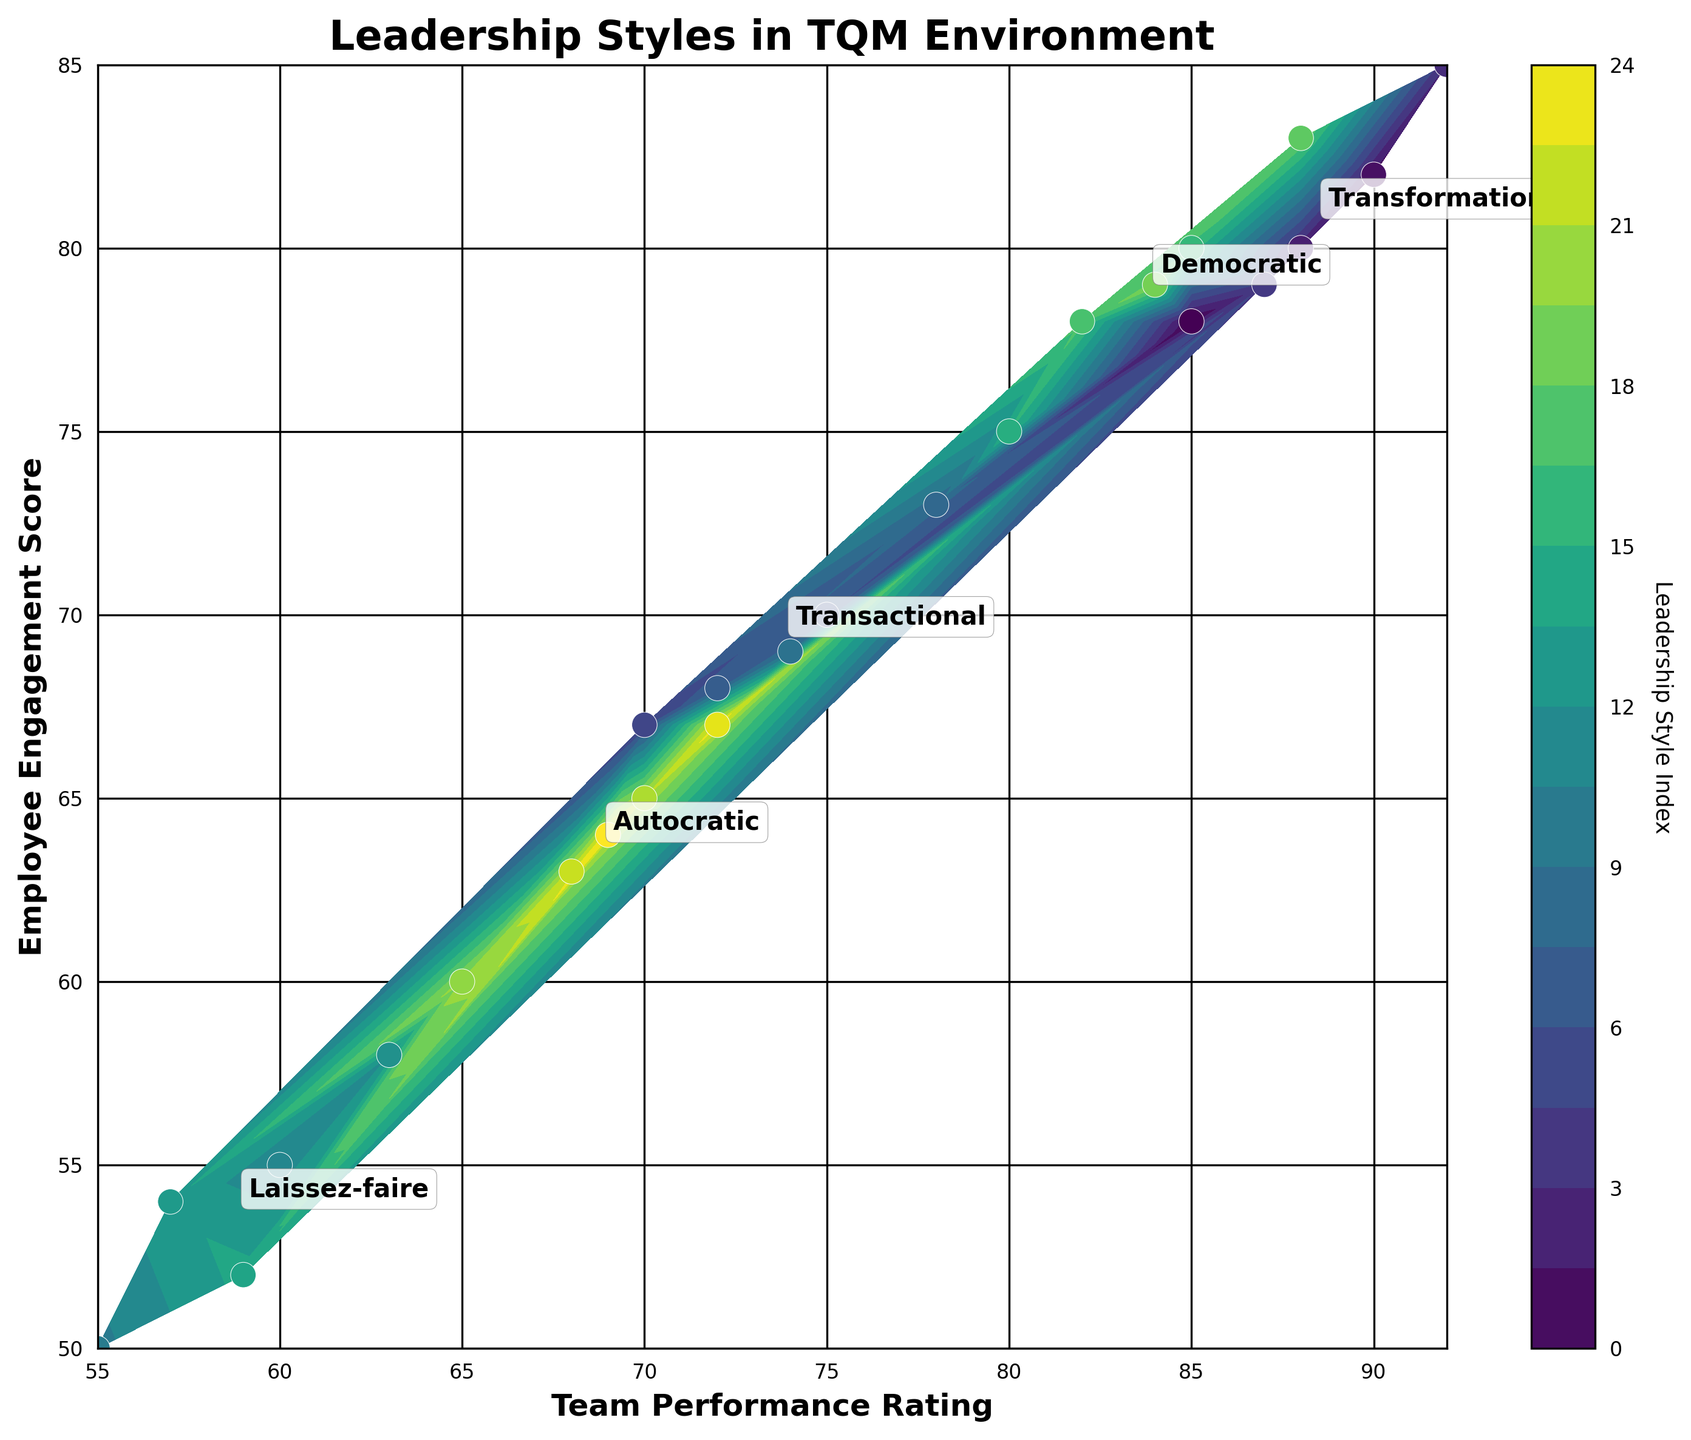What is the title of the plot? The title of a plot is usually found at the top of the figure. It summarizes what the plot is about in a concise manner. In this case, the title gives insight into the topic being visualized.
Answer: Leadership Styles in TQM Environment How many unique leadership styles are represented in the plot? The plot includes annotations for each leadership style, located near the clusters of data points that share the same style. By counting these annotations, we determine the number of unique styles.
Answer: 5 Which leadership style has the highest average Team Performance Rating? The annotations near the clusters indicate the mean Team Performance Rating for each leadership style. We compare these mean values to find the highest one.
Answer: Transformational What is the range of Employee Engagement Scores observed in the plot? Observing the y-axis, the lowest and highest Employee Engagement Scores can be identified. Subtracting the minimum value from the maximum value gives the range.
Answer: 50 to 85 Which leadership style shows the lowest Team Performance Rating? By examining the clusters of points and their annotations, the leadership style with data points furthest down the x-axis is identified.
Answer: Laissez-faire Compare the average Employee Engagement Score of Transformational and Autocratic leadership styles. Which is higher? The annotations near the data point clusters for each leadership style indicate their average Employee Engagement Scores. Comparing these values tells us which one is higher.
Answer: Transformational What color map is used for the contour plot? The specific color map (also known as the color palette or gradient) can be identified by observing the spectrum of colors used from the plot.
Answer: Viridis How do the Team Performance Ratings and Employee Engagement Scores for Transformational leadership compare to those for Laissez-faire leadership? To compare the data, we observe clusters and annotations for both Transformational and Laissez-faire leadership. Transformational has higher Team Performance Ratings and Employee Engagement Scores compared to Laissez-faire, based on their positions on the x and y axes.
Answer: Higher in both ratings for Transformational Identify the correlation between Team Performance Rating and Employee Engagement Score based on the shape of the contour plot. By looking at the general trend of the contour lines, if they show a pattern where higher Team Performance Ratings are associated with higher Employee Engagement Scores, we can deduce a positive correlation.
Answer: Positive correlation 